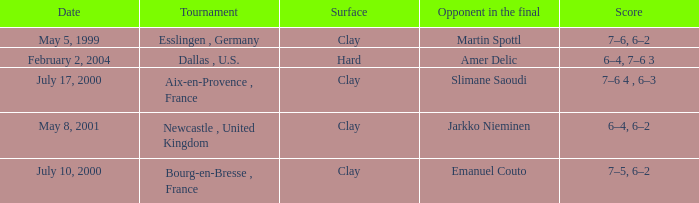Give me the full table as a dictionary. {'header': ['Date', 'Tournament', 'Surface', 'Opponent in the final', 'Score'], 'rows': [['May 5, 1999', 'Esslingen , Germany', 'Clay', 'Martin Spottl', '7–6, 6–2'], ['February 2, 2004', 'Dallas , U.S.', 'Hard', 'Amer Delic', '6–4, 7–6 3'], ['July 17, 2000', 'Aix-en-Provence , France', 'Clay', 'Slimane Saoudi', '7–6 4 , 6–3'], ['May 8, 2001', 'Newcastle , United Kingdom', 'Clay', 'Jarkko Nieminen', '6–4, 6–2'], ['July 10, 2000', 'Bourg-en-Bresse , France', 'Clay', 'Emanuel Couto', '7–5, 6–2']]} What is the Opponent in the final of the game on february 2, 2004? Amer Delic. 